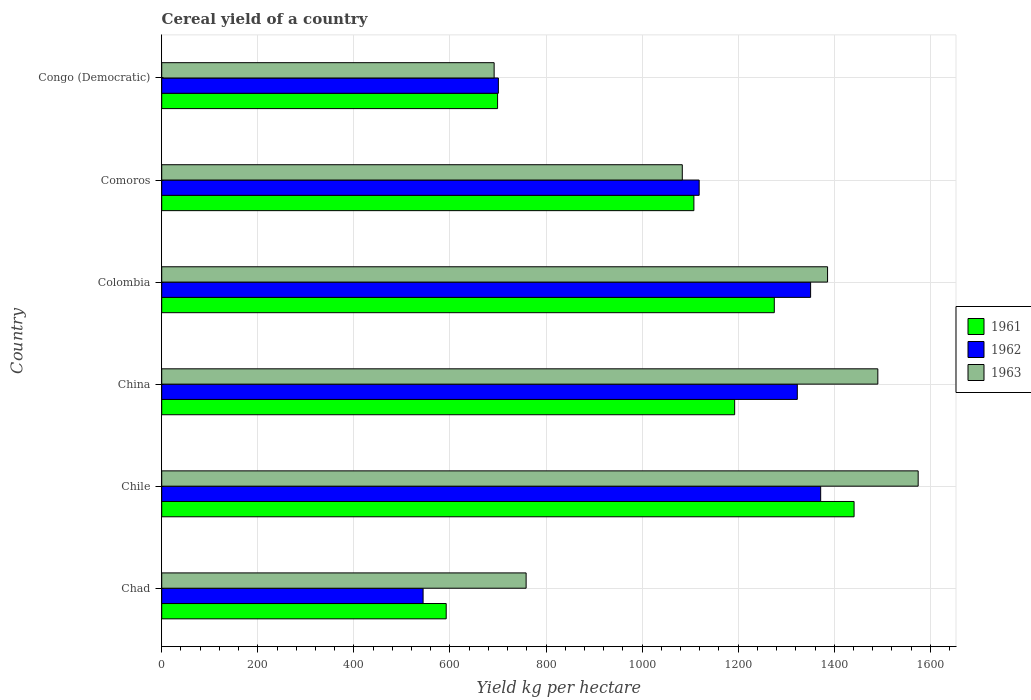How many different coloured bars are there?
Give a very brief answer. 3. Are the number of bars per tick equal to the number of legend labels?
Provide a succinct answer. Yes. How many bars are there on the 3rd tick from the bottom?
Offer a terse response. 3. What is the label of the 5th group of bars from the top?
Provide a short and direct response. Chile. In how many cases, is the number of bars for a given country not equal to the number of legend labels?
Offer a terse response. 0. What is the total cereal yield in 1962 in Chad?
Provide a succinct answer. 544.13. Across all countries, what is the maximum total cereal yield in 1962?
Your answer should be compact. 1371.74. Across all countries, what is the minimum total cereal yield in 1963?
Give a very brief answer. 692.02. In which country was the total cereal yield in 1961 maximum?
Offer a terse response. Chile. In which country was the total cereal yield in 1961 minimum?
Offer a terse response. Chad. What is the total total cereal yield in 1961 in the graph?
Your response must be concise. 6308.48. What is the difference between the total cereal yield in 1963 in Chad and that in China?
Ensure brevity in your answer.  -732.14. What is the difference between the total cereal yield in 1962 in Chile and the total cereal yield in 1961 in Congo (Democratic)?
Your answer should be compact. 672.57. What is the average total cereal yield in 1962 per country?
Your answer should be compact. 1068.24. What is the difference between the total cereal yield in 1963 and total cereal yield in 1961 in Colombia?
Your answer should be compact. 110.89. What is the ratio of the total cereal yield in 1963 in Colombia to that in Congo (Democratic)?
Provide a short and direct response. 2. Is the total cereal yield in 1962 in Colombia less than that in Congo (Democratic)?
Give a very brief answer. No. What is the difference between the highest and the second highest total cereal yield in 1961?
Give a very brief answer. 166.09. What is the difference between the highest and the lowest total cereal yield in 1961?
Offer a terse response. 849.07. In how many countries, is the total cereal yield in 1963 greater than the average total cereal yield in 1963 taken over all countries?
Offer a very short reply. 3. What does the 3rd bar from the top in China represents?
Your answer should be very brief. 1961. What does the 1st bar from the bottom in Chad represents?
Offer a terse response. 1961. Is it the case that in every country, the sum of the total cereal yield in 1961 and total cereal yield in 1963 is greater than the total cereal yield in 1962?
Offer a very short reply. Yes. Are all the bars in the graph horizontal?
Keep it short and to the point. Yes. How many countries are there in the graph?
Your answer should be very brief. 6. What is the title of the graph?
Offer a terse response. Cereal yield of a country. Does "1996" appear as one of the legend labels in the graph?
Provide a short and direct response. No. What is the label or title of the X-axis?
Your response must be concise. Yield kg per hectare. What is the label or title of the Y-axis?
Provide a succinct answer. Country. What is the Yield kg per hectare in 1961 in Chad?
Offer a terse response. 592.23. What is the Yield kg per hectare in 1962 in Chad?
Provide a short and direct response. 544.13. What is the Yield kg per hectare in 1963 in Chad?
Offer a terse response. 758.6. What is the Yield kg per hectare of 1961 in Chile?
Your answer should be very brief. 1441.31. What is the Yield kg per hectare of 1962 in Chile?
Offer a very short reply. 1371.74. What is the Yield kg per hectare of 1963 in Chile?
Make the answer very short. 1574.71. What is the Yield kg per hectare in 1961 in China?
Give a very brief answer. 1192.71. What is the Yield kg per hectare of 1962 in China?
Your answer should be compact. 1323.14. What is the Yield kg per hectare of 1963 in China?
Your answer should be compact. 1490.74. What is the Yield kg per hectare of 1961 in Colombia?
Make the answer very short. 1275.22. What is the Yield kg per hectare in 1962 in Colombia?
Make the answer very short. 1350.8. What is the Yield kg per hectare of 1963 in Colombia?
Your response must be concise. 1386.11. What is the Yield kg per hectare of 1961 in Comoros?
Offer a very short reply. 1107.84. What is the Yield kg per hectare in 1962 in Comoros?
Provide a succinct answer. 1118.81. What is the Yield kg per hectare in 1963 in Comoros?
Ensure brevity in your answer.  1083.7. What is the Yield kg per hectare of 1961 in Congo (Democratic)?
Your answer should be very brief. 699.17. What is the Yield kg per hectare of 1962 in Congo (Democratic)?
Give a very brief answer. 700.84. What is the Yield kg per hectare of 1963 in Congo (Democratic)?
Ensure brevity in your answer.  692.02. Across all countries, what is the maximum Yield kg per hectare in 1961?
Keep it short and to the point. 1441.31. Across all countries, what is the maximum Yield kg per hectare in 1962?
Keep it short and to the point. 1371.74. Across all countries, what is the maximum Yield kg per hectare of 1963?
Provide a short and direct response. 1574.71. Across all countries, what is the minimum Yield kg per hectare in 1961?
Offer a terse response. 592.23. Across all countries, what is the minimum Yield kg per hectare of 1962?
Your response must be concise. 544.13. Across all countries, what is the minimum Yield kg per hectare in 1963?
Your answer should be very brief. 692.02. What is the total Yield kg per hectare of 1961 in the graph?
Make the answer very short. 6308.48. What is the total Yield kg per hectare in 1962 in the graph?
Offer a very short reply. 6409.45. What is the total Yield kg per hectare in 1963 in the graph?
Your answer should be compact. 6985.89. What is the difference between the Yield kg per hectare in 1961 in Chad and that in Chile?
Your response must be concise. -849.08. What is the difference between the Yield kg per hectare of 1962 in Chad and that in Chile?
Provide a succinct answer. -827.61. What is the difference between the Yield kg per hectare in 1963 in Chad and that in Chile?
Keep it short and to the point. -816.11. What is the difference between the Yield kg per hectare of 1961 in Chad and that in China?
Provide a short and direct response. -600.47. What is the difference between the Yield kg per hectare in 1962 in Chad and that in China?
Offer a terse response. -779. What is the difference between the Yield kg per hectare of 1963 in Chad and that in China?
Offer a very short reply. -732.14. What is the difference between the Yield kg per hectare of 1961 in Chad and that in Colombia?
Provide a short and direct response. -682.99. What is the difference between the Yield kg per hectare of 1962 in Chad and that in Colombia?
Your answer should be very brief. -806.67. What is the difference between the Yield kg per hectare of 1963 in Chad and that in Colombia?
Keep it short and to the point. -627.51. What is the difference between the Yield kg per hectare of 1961 in Chad and that in Comoros?
Make the answer very short. -515.61. What is the difference between the Yield kg per hectare in 1962 in Chad and that in Comoros?
Your answer should be very brief. -574.68. What is the difference between the Yield kg per hectare in 1963 in Chad and that in Comoros?
Keep it short and to the point. -325.1. What is the difference between the Yield kg per hectare in 1961 in Chad and that in Congo (Democratic)?
Provide a short and direct response. -106.94. What is the difference between the Yield kg per hectare of 1962 in Chad and that in Congo (Democratic)?
Make the answer very short. -156.7. What is the difference between the Yield kg per hectare of 1963 in Chad and that in Congo (Democratic)?
Give a very brief answer. 66.58. What is the difference between the Yield kg per hectare in 1961 in Chile and that in China?
Ensure brevity in your answer.  248.6. What is the difference between the Yield kg per hectare of 1962 in Chile and that in China?
Offer a terse response. 48.6. What is the difference between the Yield kg per hectare of 1963 in Chile and that in China?
Your answer should be compact. 83.97. What is the difference between the Yield kg per hectare of 1961 in Chile and that in Colombia?
Your answer should be compact. 166.09. What is the difference between the Yield kg per hectare in 1962 in Chile and that in Colombia?
Give a very brief answer. 20.94. What is the difference between the Yield kg per hectare of 1963 in Chile and that in Colombia?
Ensure brevity in your answer.  188.6. What is the difference between the Yield kg per hectare in 1961 in Chile and that in Comoros?
Offer a very short reply. 333.46. What is the difference between the Yield kg per hectare in 1962 in Chile and that in Comoros?
Provide a succinct answer. 252.93. What is the difference between the Yield kg per hectare in 1963 in Chile and that in Comoros?
Offer a very short reply. 491.01. What is the difference between the Yield kg per hectare in 1961 in Chile and that in Congo (Democratic)?
Your answer should be compact. 742.14. What is the difference between the Yield kg per hectare of 1962 in Chile and that in Congo (Democratic)?
Offer a very short reply. 670.9. What is the difference between the Yield kg per hectare of 1963 in Chile and that in Congo (Democratic)?
Your answer should be very brief. 882.69. What is the difference between the Yield kg per hectare in 1961 in China and that in Colombia?
Offer a terse response. -82.51. What is the difference between the Yield kg per hectare in 1962 in China and that in Colombia?
Your answer should be very brief. -27.66. What is the difference between the Yield kg per hectare in 1963 in China and that in Colombia?
Your response must be concise. 104.63. What is the difference between the Yield kg per hectare in 1961 in China and that in Comoros?
Your response must be concise. 84.86. What is the difference between the Yield kg per hectare in 1962 in China and that in Comoros?
Ensure brevity in your answer.  204.32. What is the difference between the Yield kg per hectare of 1963 in China and that in Comoros?
Give a very brief answer. 407.04. What is the difference between the Yield kg per hectare of 1961 in China and that in Congo (Democratic)?
Keep it short and to the point. 493.53. What is the difference between the Yield kg per hectare in 1962 in China and that in Congo (Democratic)?
Ensure brevity in your answer.  622.3. What is the difference between the Yield kg per hectare of 1963 in China and that in Congo (Democratic)?
Your answer should be very brief. 798.72. What is the difference between the Yield kg per hectare in 1961 in Colombia and that in Comoros?
Give a very brief answer. 167.38. What is the difference between the Yield kg per hectare of 1962 in Colombia and that in Comoros?
Ensure brevity in your answer.  231.99. What is the difference between the Yield kg per hectare of 1963 in Colombia and that in Comoros?
Your response must be concise. 302.41. What is the difference between the Yield kg per hectare in 1961 in Colombia and that in Congo (Democratic)?
Offer a very short reply. 576.05. What is the difference between the Yield kg per hectare of 1962 in Colombia and that in Congo (Democratic)?
Keep it short and to the point. 649.96. What is the difference between the Yield kg per hectare in 1963 in Colombia and that in Congo (Democratic)?
Provide a succinct answer. 694.09. What is the difference between the Yield kg per hectare in 1961 in Comoros and that in Congo (Democratic)?
Make the answer very short. 408.67. What is the difference between the Yield kg per hectare in 1962 in Comoros and that in Congo (Democratic)?
Ensure brevity in your answer.  417.98. What is the difference between the Yield kg per hectare of 1963 in Comoros and that in Congo (Democratic)?
Provide a short and direct response. 391.68. What is the difference between the Yield kg per hectare in 1961 in Chad and the Yield kg per hectare in 1962 in Chile?
Your response must be concise. -779.5. What is the difference between the Yield kg per hectare in 1961 in Chad and the Yield kg per hectare in 1963 in Chile?
Give a very brief answer. -982.48. What is the difference between the Yield kg per hectare in 1962 in Chad and the Yield kg per hectare in 1963 in Chile?
Your response must be concise. -1030.58. What is the difference between the Yield kg per hectare of 1961 in Chad and the Yield kg per hectare of 1962 in China?
Ensure brevity in your answer.  -730.9. What is the difference between the Yield kg per hectare of 1961 in Chad and the Yield kg per hectare of 1963 in China?
Offer a terse response. -898.51. What is the difference between the Yield kg per hectare in 1962 in Chad and the Yield kg per hectare in 1963 in China?
Provide a short and direct response. -946.61. What is the difference between the Yield kg per hectare of 1961 in Chad and the Yield kg per hectare of 1962 in Colombia?
Provide a short and direct response. -758.57. What is the difference between the Yield kg per hectare of 1961 in Chad and the Yield kg per hectare of 1963 in Colombia?
Offer a very short reply. -793.88. What is the difference between the Yield kg per hectare of 1962 in Chad and the Yield kg per hectare of 1963 in Colombia?
Provide a succinct answer. -841.98. What is the difference between the Yield kg per hectare of 1961 in Chad and the Yield kg per hectare of 1962 in Comoros?
Offer a terse response. -526.58. What is the difference between the Yield kg per hectare of 1961 in Chad and the Yield kg per hectare of 1963 in Comoros?
Your response must be concise. -491.47. What is the difference between the Yield kg per hectare in 1962 in Chad and the Yield kg per hectare in 1963 in Comoros?
Your answer should be compact. -539.57. What is the difference between the Yield kg per hectare in 1961 in Chad and the Yield kg per hectare in 1962 in Congo (Democratic)?
Keep it short and to the point. -108.6. What is the difference between the Yield kg per hectare in 1961 in Chad and the Yield kg per hectare in 1963 in Congo (Democratic)?
Offer a very short reply. -99.79. What is the difference between the Yield kg per hectare of 1962 in Chad and the Yield kg per hectare of 1963 in Congo (Democratic)?
Ensure brevity in your answer.  -147.89. What is the difference between the Yield kg per hectare of 1961 in Chile and the Yield kg per hectare of 1962 in China?
Offer a very short reply. 118.17. What is the difference between the Yield kg per hectare in 1961 in Chile and the Yield kg per hectare in 1963 in China?
Keep it short and to the point. -49.44. What is the difference between the Yield kg per hectare of 1962 in Chile and the Yield kg per hectare of 1963 in China?
Give a very brief answer. -119.01. What is the difference between the Yield kg per hectare in 1961 in Chile and the Yield kg per hectare in 1962 in Colombia?
Ensure brevity in your answer.  90.51. What is the difference between the Yield kg per hectare in 1961 in Chile and the Yield kg per hectare in 1963 in Colombia?
Provide a short and direct response. 55.2. What is the difference between the Yield kg per hectare of 1962 in Chile and the Yield kg per hectare of 1963 in Colombia?
Offer a terse response. -14.37. What is the difference between the Yield kg per hectare of 1961 in Chile and the Yield kg per hectare of 1962 in Comoros?
Your answer should be very brief. 322.5. What is the difference between the Yield kg per hectare in 1961 in Chile and the Yield kg per hectare in 1963 in Comoros?
Ensure brevity in your answer.  357.61. What is the difference between the Yield kg per hectare in 1962 in Chile and the Yield kg per hectare in 1963 in Comoros?
Your answer should be very brief. 288.04. What is the difference between the Yield kg per hectare of 1961 in Chile and the Yield kg per hectare of 1962 in Congo (Democratic)?
Keep it short and to the point. 740.47. What is the difference between the Yield kg per hectare of 1961 in Chile and the Yield kg per hectare of 1963 in Congo (Democratic)?
Provide a succinct answer. 749.29. What is the difference between the Yield kg per hectare in 1962 in Chile and the Yield kg per hectare in 1963 in Congo (Democratic)?
Offer a terse response. 679.72. What is the difference between the Yield kg per hectare of 1961 in China and the Yield kg per hectare of 1962 in Colombia?
Your answer should be very brief. -158.09. What is the difference between the Yield kg per hectare in 1961 in China and the Yield kg per hectare in 1963 in Colombia?
Offer a terse response. -193.41. What is the difference between the Yield kg per hectare of 1962 in China and the Yield kg per hectare of 1963 in Colombia?
Ensure brevity in your answer.  -62.98. What is the difference between the Yield kg per hectare of 1961 in China and the Yield kg per hectare of 1962 in Comoros?
Keep it short and to the point. 73.89. What is the difference between the Yield kg per hectare in 1961 in China and the Yield kg per hectare in 1963 in Comoros?
Ensure brevity in your answer.  109.01. What is the difference between the Yield kg per hectare in 1962 in China and the Yield kg per hectare in 1963 in Comoros?
Your response must be concise. 239.44. What is the difference between the Yield kg per hectare of 1961 in China and the Yield kg per hectare of 1962 in Congo (Democratic)?
Give a very brief answer. 491.87. What is the difference between the Yield kg per hectare in 1961 in China and the Yield kg per hectare in 1963 in Congo (Democratic)?
Provide a short and direct response. 500.69. What is the difference between the Yield kg per hectare of 1962 in China and the Yield kg per hectare of 1963 in Congo (Democratic)?
Offer a very short reply. 631.12. What is the difference between the Yield kg per hectare in 1961 in Colombia and the Yield kg per hectare in 1962 in Comoros?
Provide a short and direct response. 156.41. What is the difference between the Yield kg per hectare in 1961 in Colombia and the Yield kg per hectare in 1963 in Comoros?
Provide a succinct answer. 191.52. What is the difference between the Yield kg per hectare of 1962 in Colombia and the Yield kg per hectare of 1963 in Comoros?
Your answer should be compact. 267.1. What is the difference between the Yield kg per hectare in 1961 in Colombia and the Yield kg per hectare in 1962 in Congo (Democratic)?
Your answer should be very brief. 574.38. What is the difference between the Yield kg per hectare in 1961 in Colombia and the Yield kg per hectare in 1963 in Congo (Democratic)?
Offer a terse response. 583.2. What is the difference between the Yield kg per hectare of 1962 in Colombia and the Yield kg per hectare of 1963 in Congo (Democratic)?
Provide a short and direct response. 658.78. What is the difference between the Yield kg per hectare in 1961 in Comoros and the Yield kg per hectare in 1962 in Congo (Democratic)?
Provide a succinct answer. 407.01. What is the difference between the Yield kg per hectare in 1961 in Comoros and the Yield kg per hectare in 1963 in Congo (Democratic)?
Give a very brief answer. 415.82. What is the difference between the Yield kg per hectare in 1962 in Comoros and the Yield kg per hectare in 1963 in Congo (Democratic)?
Your answer should be compact. 426.79. What is the average Yield kg per hectare of 1961 per country?
Make the answer very short. 1051.41. What is the average Yield kg per hectare in 1962 per country?
Your answer should be very brief. 1068.24. What is the average Yield kg per hectare of 1963 per country?
Give a very brief answer. 1164.32. What is the difference between the Yield kg per hectare in 1961 and Yield kg per hectare in 1962 in Chad?
Provide a succinct answer. 48.1. What is the difference between the Yield kg per hectare in 1961 and Yield kg per hectare in 1963 in Chad?
Make the answer very short. -166.37. What is the difference between the Yield kg per hectare of 1962 and Yield kg per hectare of 1963 in Chad?
Keep it short and to the point. -214.47. What is the difference between the Yield kg per hectare of 1961 and Yield kg per hectare of 1962 in Chile?
Provide a short and direct response. 69.57. What is the difference between the Yield kg per hectare of 1961 and Yield kg per hectare of 1963 in Chile?
Provide a succinct answer. -133.41. What is the difference between the Yield kg per hectare in 1962 and Yield kg per hectare in 1963 in Chile?
Keep it short and to the point. -202.98. What is the difference between the Yield kg per hectare of 1961 and Yield kg per hectare of 1962 in China?
Provide a short and direct response. -130.43. What is the difference between the Yield kg per hectare in 1961 and Yield kg per hectare in 1963 in China?
Offer a very short reply. -298.04. What is the difference between the Yield kg per hectare of 1962 and Yield kg per hectare of 1963 in China?
Provide a succinct answer. -167.61. What is the difference between the Yield kg per hectare of 1961 and Yield kg per hectare of 1962 in Colombia?
Offer a terse response. -75.58. What is the difference between the Yield kg per hectare of 1961 and Yield kg per hectare of 1963 in Colombia?
Make the answer very short. -110.89. What is the difference between the Yield kg per hectare of 1962 and Yield kg per hectare of 1963 in Colombia?
Give a very brief answer. -35.31. What is the difference between the Yield kg per hectare in 1961 and Yield kg per hectare in 1962 in Comoros?
Your answer should be compact. -10.97. What is the difference between the Yield kg per hectare in 1961 and Yield kg per hectare in 1963 in Comoros?
Make the answer very short. 24.14. What is the difference between the Yield kg per hectare of 1962 and Yield kg per hectare of 1963 in Comoros?
Your answer should be very brief. 35.11. What is the difference between the Yield kg per hectare in 1961 and Yield kg per hectare in 1962 in Congo (Democratic)?
Provide a short and direct response. -1.66. What is the difference between the Yield kg per hectare of 1961 and Yield kg per hectare of 1963 in Congo (Democratic)?
Provide a short and direct response. 7.15. What is the difference between the Yield kg per hectare in 1962 and Yield kg per hectare in 1963 in Congo (Democratic)?
Keep it short and to the point. 8.81. What is the ratio of the Yield kg per hectare in 1961 in Chad to that in Chile?
Provide a short and direct response. 0.41. What is the ratio of the Yield kg per hectare of 1962 in Chad to that in Chile?
Provide a short and direct response. 0.4. What is the ratio of the Yield kg per hectare in 1963 in Chad to that in Chile?
Make the answer very short. 0.48. What is the ratio of the Yield kg per hectare of 1961 in Chad to that in China?
Ensure brevity in your answer.  0.5. What is the ratio of the Yield kg per hectare in 1962 in Chad to that in China?
Make the answer very short. 0.41. What is the ratio of the Yield kg per hectare of 1963 in Chad to that in China?
Provide a short and direct response. 0.51. What is the ratio of the Yield kg per hectare of 1961 in Chad to that in Colombia?
Your answer should be very brief. 0.46. What is the ratio of the Yield kg per hectare in 1962 in Chad to that in Colombia?
Provide a short and direct response. 0.4. What is the ratio of the Yield kg per hectare of 1963 in Chad to that in Colombia?
Give a very brief answer. 0.55. What is the ratio of the Yield kg per hectare in 1961 in Chad to that in Comoros?
Offer a terse response. 0.53. What is the ratio of the Yield kg per hectare of 1962 in Chad to that in Comoros?
Make the answer very short. 0.49. What is the ratio of the Yield kg per hectare of 1963 in Chad to that in Comoros?
Your answer should be compact. 0.7. What is the ratio of the Yield kg per hectare in 1961 in Chad to that in Congo (Democratic)?
Give a very brief answer. 0.85. What is the ratio of the Yield kg per hectare of 1962 in Chad to that in Congo (Democratic)?
Ensure brevity in your answer.  0.78. What is the ratio of the Yield kg per hectare of 1963 in Chad to that in Congo (Democratic)?
Keep it short and to the point. 1.1. What is the ratio of the Yield kg per hectare of 1961 in Chile to that in China?
Keep it short and to the point. 1.21. What is the ratio of the Yield kg per hectare in 1962 in Chile to that in China?
Give a very brief answer. 1.04. What is the ratio of the Yield kg per hectare in 1963 in Chile to that in China?
Your response must be concise. 1.06. What is the ratio of the Yield kg per hectare of 1961 in Chile to that in Colombia?
Your answer should be compact. 1.13. What is the ratio of the Yield kg per hectare in 1962 in Chile to that in Colombia?
Make the answer very short. 1.02. What is the ratio of the Yield kg per hectare in 1963 in Chile to that in Colombia?
Offer a terse response. 1.14. What is the ratio of the Yield kg per hectare of 1961 in Chile to that in Comoros?
Provide a succinct answer. 1.3. What is the ratio of the Yield kg per hectare in 1962 in Chile to that in Comoros?
Your answer should be very brief. 1.23. What is the ratio of the Yield kg per hectare of 1963 in Chile to that in Comoros?
Offer a terse response. 1.45. What is the ratio of the Yield kg per hectare in 1961 in Chile to that in Congo (Democratic)?
Keep it short and to the point. 2.06. What is the ratio of the Yield kg per hectare in 1962 in Chile to that in Congo (Democratic)?
Give a very brief answer. 1.96. What is the ratio of the Yield kg per hectare of 1963 in Chile to that in Congo (Democratic)?
Offer a very short reply. 2.28. What is the ratio of the Yield kg per hectare in 1961 in China to that in Colombia?
Provide a short and direct response. 0.94. What is the ratio of the Yield kg per hectare in 1962 in China to that in Colombia?
Offer a terse response. 0.98. What is the ratio of the Yield kg per hectare of 1963 in China to that in Colombia?
Your response must be concise. 1.08. What is the ratio of the Yield kg per hectare in 1961 in China to that in Comoros?
Provide a short and direct response. 1.08. What is the ratio of the Yield kg per hectare in 1962 in China to that in Comoros?
Make the answer very short. 1.18. What is the ratio of the Yield kg per hectare of 1963 in China to that in Comoros?
Your answer should be compact. 1.38. What is the ratio of the Yield kg per hectare in 1961 in China to that in Congo (Democratic)?
Offer a terse response. 1.71. What is the ratio of the Yield kg per hectare of 1962 in China to that in Congo (Democratic)?
Ensure brevity in your answer.  1.89. What is the ratio of the Yield kg per hectare in 1963 in China to that in Congo (Democratic)?
Ensure brevity in your answer.  2.15. What is the ratio of the Yield kg per hectare in 1961 in Colombia to that in Comoros?
Your answer should be compact. 1.15. What is the ratio of the Yield kg per hectare of 1962 in Colombia to that in Comoros?
Your answer should be very brief. 1.21. What is the ratio of the Yield kg per hectare of 1963 in Colombia to that in Comoros?
Offer a very short reply. 1.28. What is the ratio of the Yield kg per hectare of 1961 in Colombia to that in Congo (Democratic)?
Provide a succinct answer. 1.82. What is the ratio of the Yield kg per hectare of 1962 in Colombia to that in Congo (Democratic)?
Your answer should be very brief. 1.93. What is the ratio of the Yield kg per hectare of 1963 in Colombia to that in Congo (Democratic)?
Offer a very short reply. 2. What is the ratio of the Yield kg per hectare in 1961 in Comoros to that in Congo (Democratic)?
Make the answer very short. 1.58. What is the ratio of the Yield kg per hectare of 1962 in Comoros to that in Congo (Democratic)?
Give a very brief answer. 1.6. What is the ratio of the Yield kg per hectare in 1963 in Comoros to that in Congo (Democratic)?
Keep it short and to the point. 1.57. What is the difference between the highest and the second highest Yield kg per hectare of 1961?
Keep it short and to the point. 166.09. What is the difference between the highest and the second highest Yield kg per hectare of 1962?
Keep it short and to the point. 20.94. What is the difference between the highest and the second highest Yield kg per hectare of 1963?
Provide a short and direct response. 83.97. What is the difference between the highest and the lowest Yield kg per hectare in 1961?
Your answer should be compact. 849.08. What is the difference between the highest and the lowest Yield kg per hectare in 1962?
Your answer should be very brief. 827.61. What is the difference between the highest and the lowest Yield kg per hectare of 1963?
Provide a succinct answer. 882.69. 